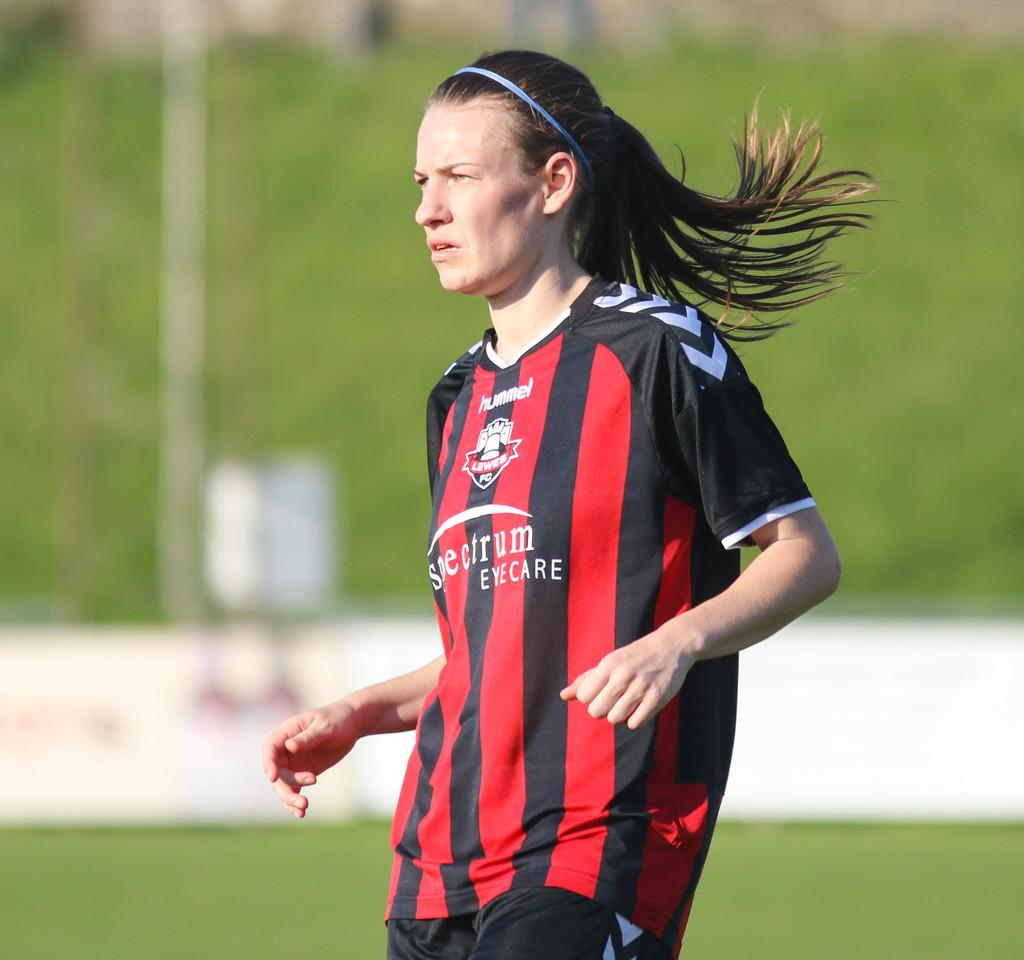<image>
Render a clear and concise summary of the photo. A player belongs to a team sponsored by spectrum eye care. 